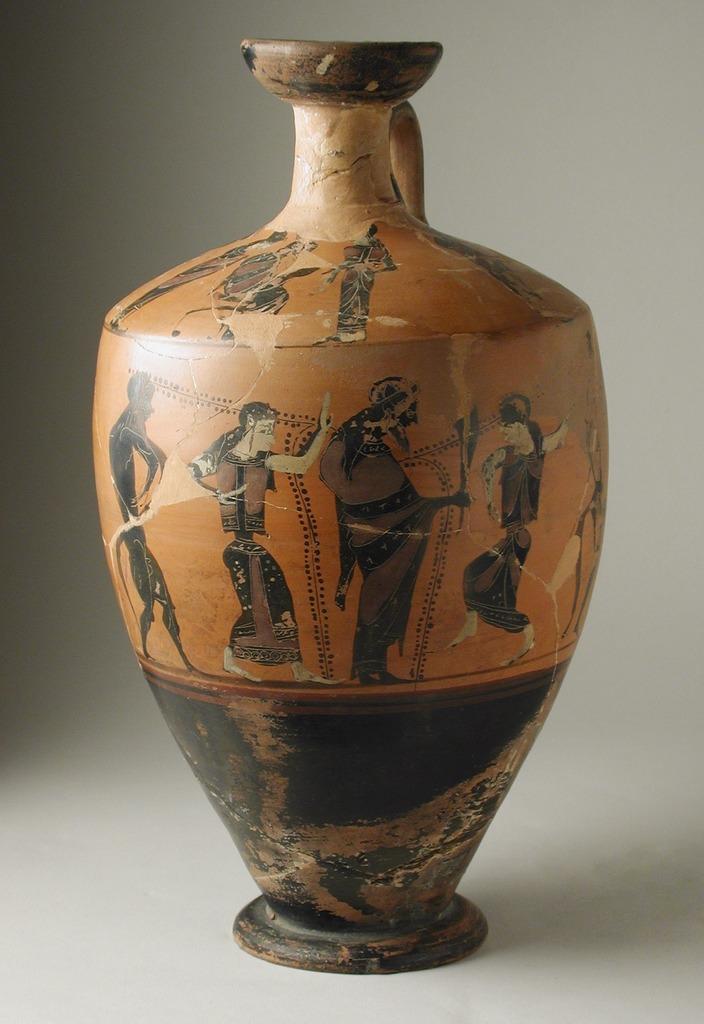Can you describe this image briefly? In this image I can see a pot, on this there is the depiction of persons. 